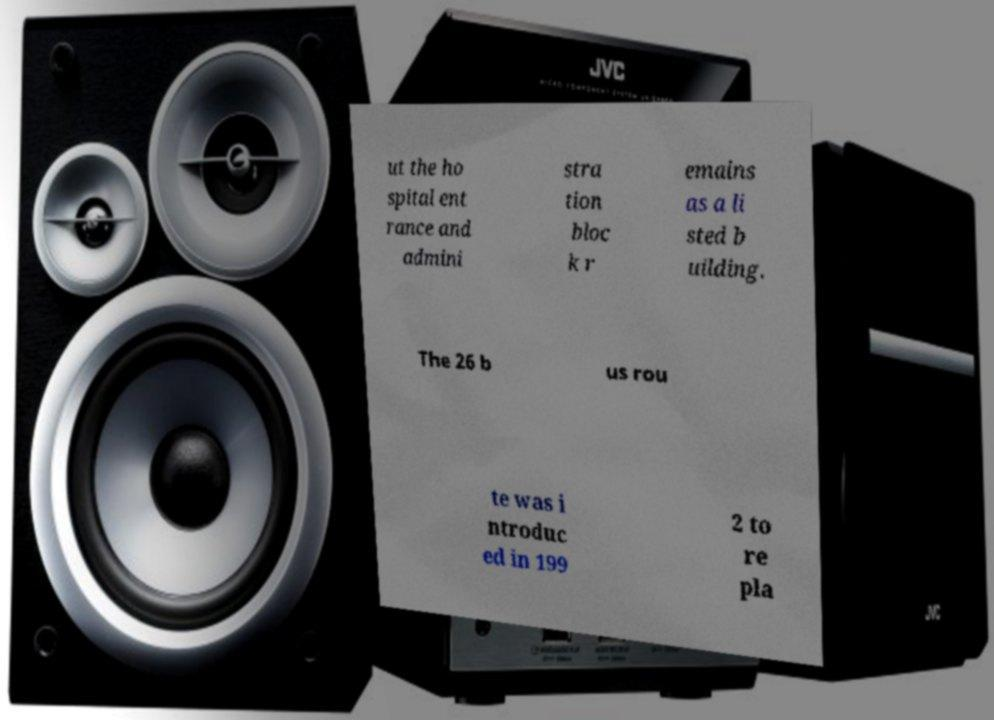What messages or text are displayed in this image? I need them in a readable, typed format. ut the ho spital ent rance and admini stra tion bloc k r emains as a li sted b uilding. The 26 b us rou te was i ntroduc ed in 199 2 to re pla 